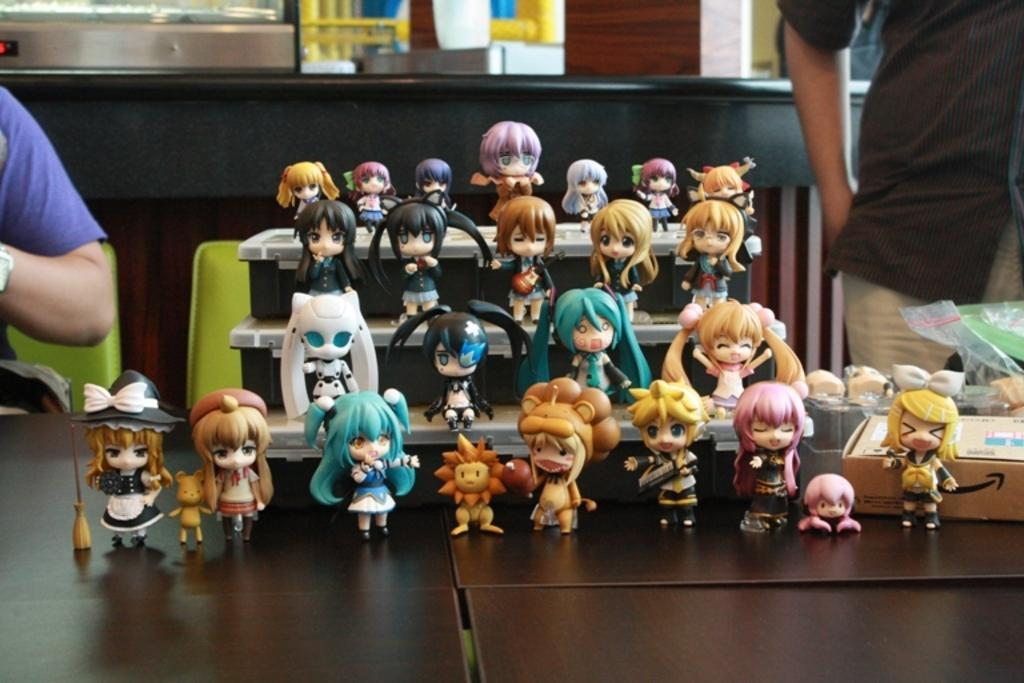What is the main subject of the image? The main subject of the image is a collection of small toys. Are there any people present in the image? Yes, there are two people around the toys. What is the background of the image? There is a table behind the toys. What type of shade is being used to protect the toys from the sun in the image? There is no shade present in the image; the toys are not being protected from the sun. 